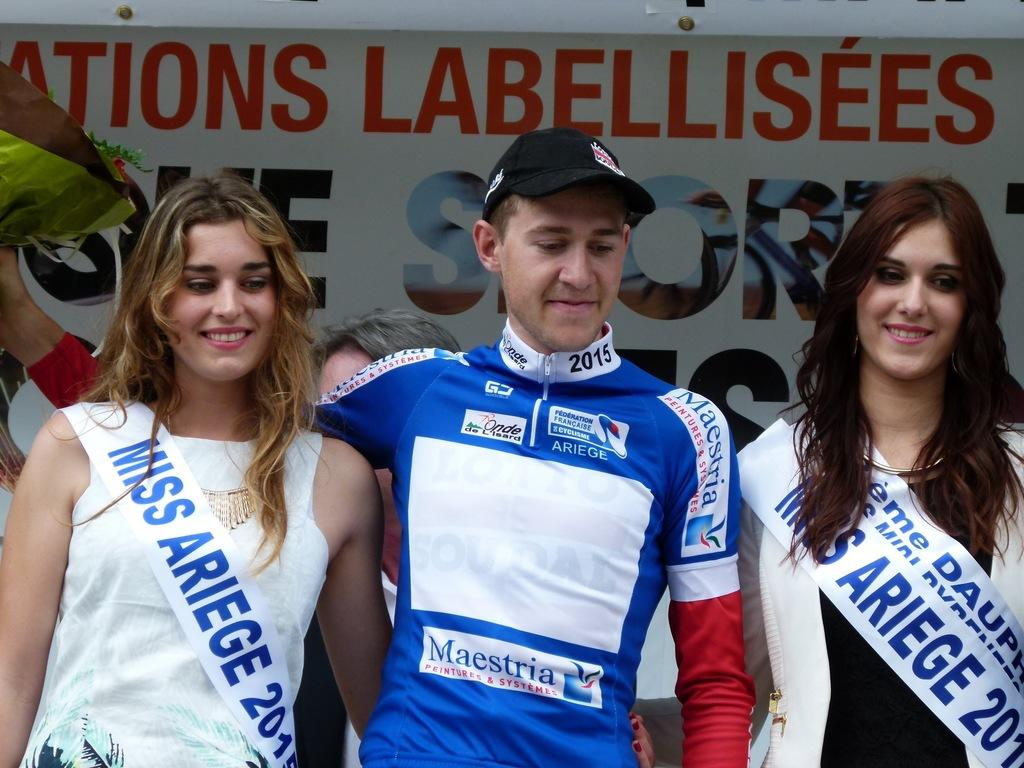<image>
Provide a brief description of the given image. A sash with the words Miss Ariege on it is being worn by a woman in a white dress. 